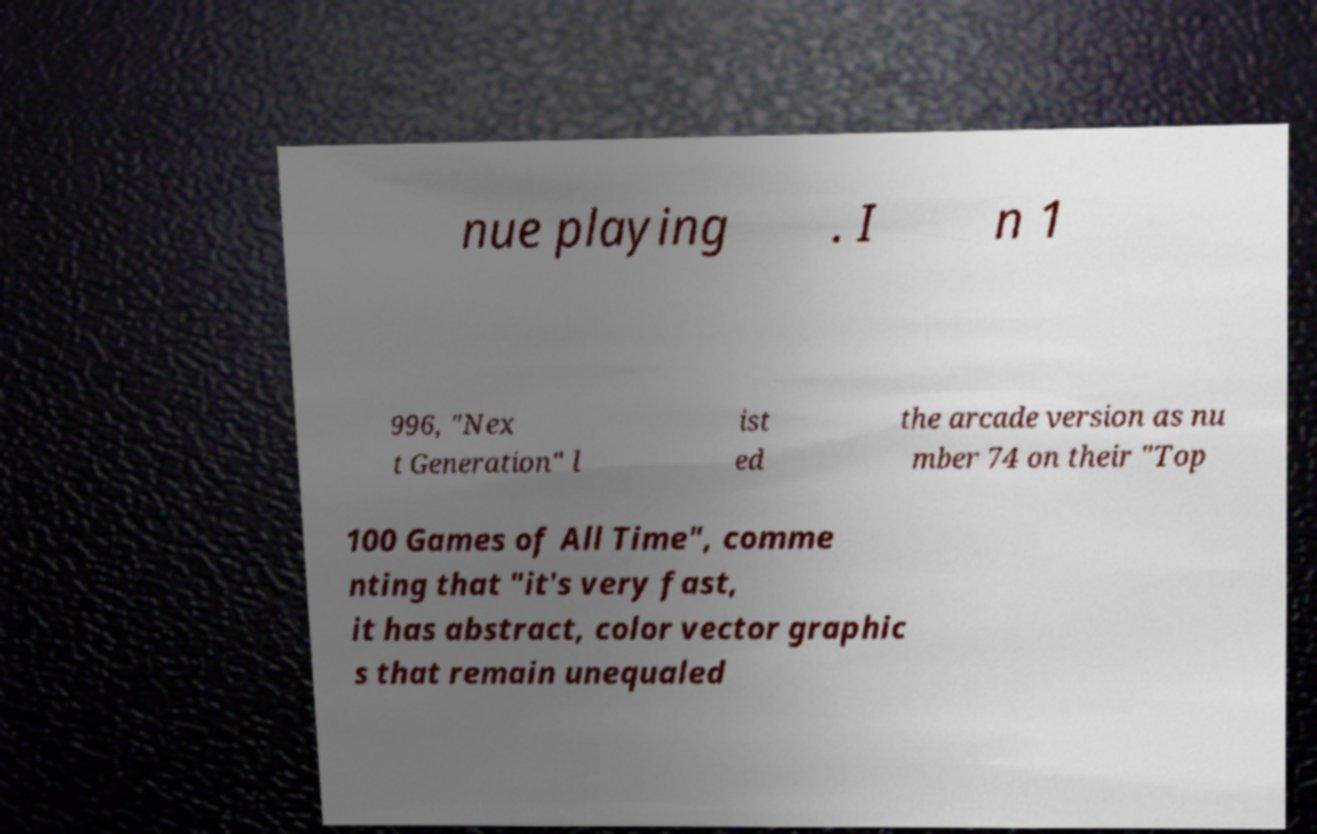Please read and relay the text visible in this image. What does it say? nue playing . I n 1 996, "Nex t Generation" l ist ed the arcade version as nu mber 74 on their "Top 100 Games of All Time", comme nting that "it's very fast, it has abstract, color vector graphic s that remain unequaled 